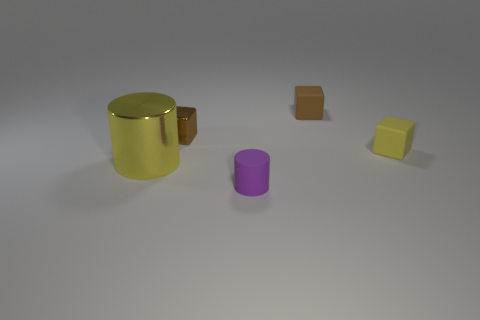Add 4 tiny blocks. How many objects exist? 9 Subtract all cylinders. How many objects are left? 3 Subtract 0 green cylinders. How many objects are left? 5 Subtract all small yellow matte things. Subtract all small brown metal blocks. How many objects are left? 3 Add 2 matte cylinders. How many matte cylinders are left? 3 Add 4 yellow metal cylinders. How many yellow metal cylinders exist? 5 